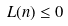<formula> <loc_0><loc_0><loc_500><loc_500>L ( n ) \leq 0</formula> 